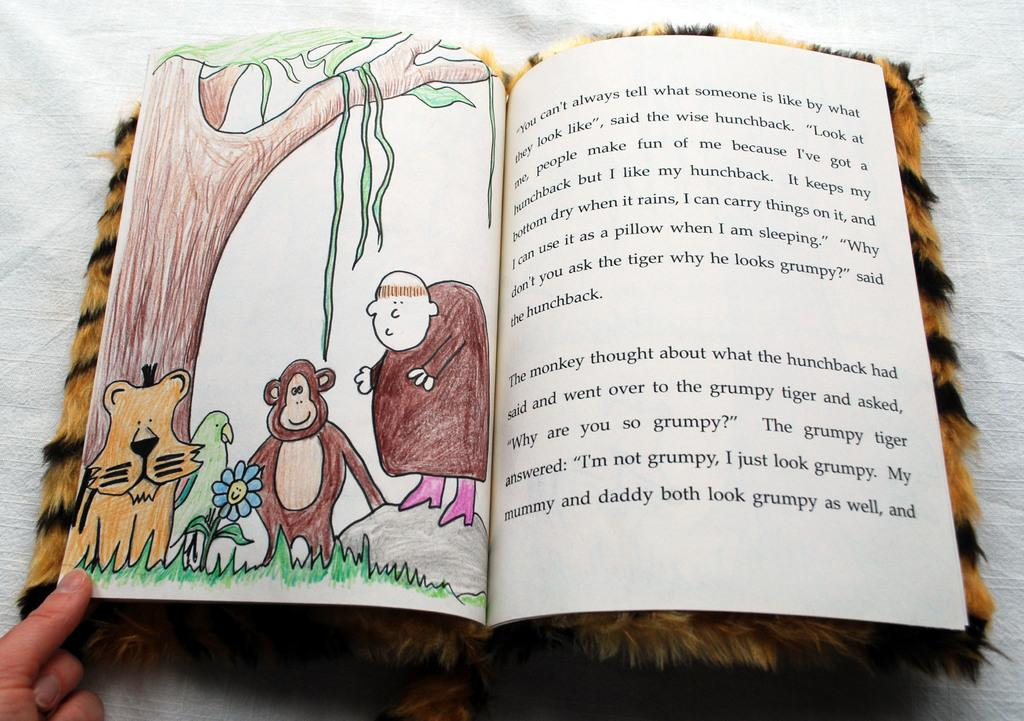<image>
Write a terse but informative summary of the picture. The book has a grumpy tiger in the story 